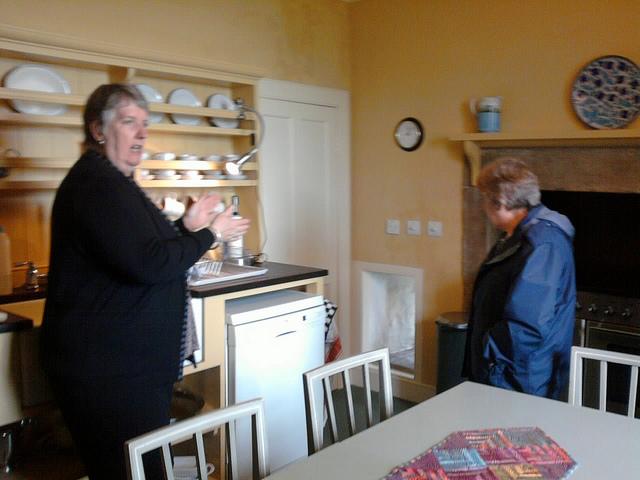Is this a room in a house?
Quick response, please. Yes. Is there a trash can?
Be succinct. Yes. Are the woman standing?
Be succinct. Yes. 